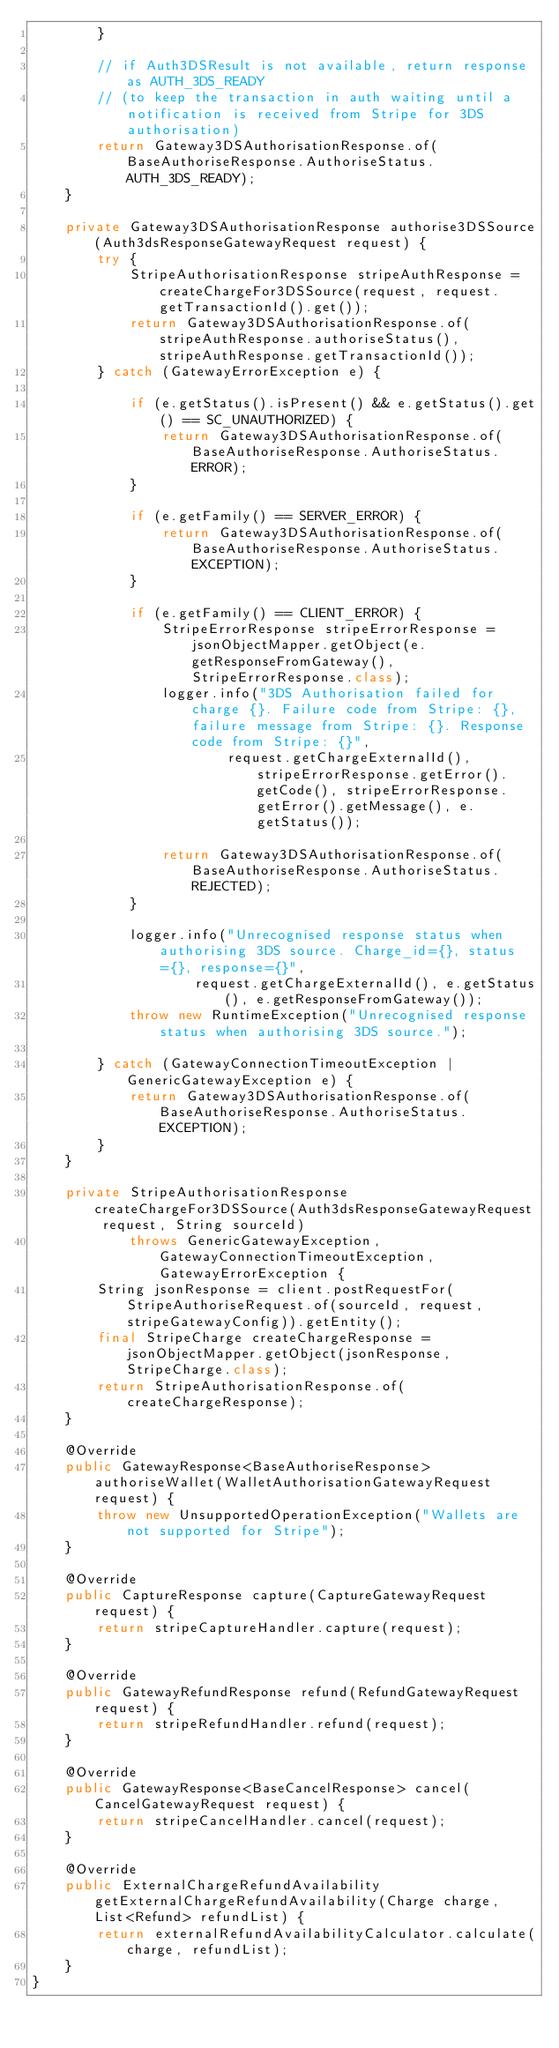<code> <loc_0><loc_0><loc_500><loc_500><_Java_>        }

        // if Auth3DSResult is not available, return response as AUTH_3DS_READY
        // (to keep the transaction in auth waiting until a notification is received from Stripe for 3DS authorisation)
        return Gateway3DSAuthorisationResponse.of(BaseAuthoriseResponse.AuthoriseStatus.AUTH_3DS_READY);
    }

    private Gateway3DSAuthorisationResponse authorise3DSSource(Auth3dsResponseGatewayRequest request) {
        try {
            StripeAuthorisationResponse stripeAuthResponse = createChargeFor3DSSource(request, request.getTransactionId().get());
            return Gateway3DSAuthorisationResponse.of(stripeAuthResponse.authoriseStatus(), stripeAuthResponse.getTransactionId());
        } catch (GatewayErrorException e) {

            if (e.getStatus().isPresent() && e.getStatus().get() == SC_UNAUTHORIZED) {
                return Gateway3DSAuthorisationResponse.of(BaseAuthoriseResponse.AuthoriseStatus.ERROR);
            }

            if (e.getFamily() == SERVER_ERROR) {
                return Gateway3DSAuthorisationResponse.of(BaseAuthoriseResponse.AuthoriseStatus.EXCEPTION);
            }

            if (e.getFamily() == CLIENT_ERROR) {
                StripeErrorResponse stripeErrorResponse = jsonObjectMapper.getObject(e.getResponseFromGateway(), StripeErrorResponse.class);
                logger.info("3DS Authorisation failed for charge {}. Failure code from Stripe: {}, failure message from Stripe: {}. Response code from Stripe: {}",
                        request.getChargeExternalId(), stripeErrorResponse.getError().getCode(), stripeErrorResponse.getError().getMessage(), e.getStatus());

                return Gateway3DSAuthorisationResponse.of(BaseAuthoriseResponse.AuthoriseStatus.REJECTED);
            }

            logger.info("Unrecognised response status when authorising 3DS source. Charge_id={}, status={}, response={}",
                    request.getChargeExternalId(), e.getStatus(), e.getResponseFromGateway());
            throw new RuntimeException("Unrecognised response status when authorising 3DS source.");

        } catch (GatewayConnectionTimeoutException | GenericGatewayException e) {
            return Gateway3DSAuthorisationResponse.of(BaseAuthoriseResponse.AuthoriseStatus.EXCEPTION);
        }
    }

    private StripeAuthorisationResponse createChargeFor3DSSource(Auth3dsResponseGatewayRequest request, String sourceId)
            throws GenericGatewayException, GatewayConnectionTimeoutException, GatewayErrorException {
        String jsonResponse = client.postRequestFor(StripeAuthoriseRequest.of(sourceId, request, stripeGatewayConfig)).getEntity();
        final StripeCharge createChargeResponse = jsonObjectMapper.getObject(jsonResponse, StripeCharge.class);
        return StripeAuthorisationResponse.of(createChargeResponse);
    }

    @Override
    public GatewayResponse<BaseAuthoriseResponse> authoriseWallet(WalletAuthorisationGatewayRequest request) {
        throw new UnsupportedOperationException("Wallets are not supported for Stripe");
    }

    @Override
    public CaptureResponse capture(CaptureGatewayRequest request) {
        return stripeCaptureHandler.capture(request);
    }

    @Override
    public GatewayRefundResponse refund(RefundGatewayRequest request) {
        return stripeRefundHandler.refund(request);
    }

    @Override
    public GatewayResponse<BaseCancelResponse> cancel(CancelGatewayRequest request) {
        return stripeCancelHandler.cancel(request);
    }

    @Override
    public ExternalChargeRefundAvailability getExternalChargeRefundAvailability(Charge charge, List<Refund> refundList) {
        return externalRefundAvailabilityCalculator.calculate(charge, refundList);
    }
}
</code> 